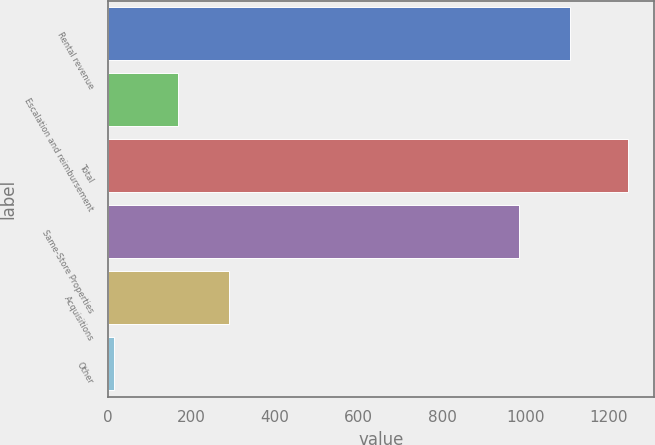<chart> <loc_0><loc_0><loc_500><loc_500><bar_chart><fcel>Rental revenue<fcel>Escalation and reimbursement<fcel>Total<fcel>Same-Store Properties<fcel>Acquisitions<fcel>Other<nl><fcel>1107.22<fcel>167.4<fcel>1245.4<fcel>984.1<fcel>290.52<fcel>14.2<nl></chart> 